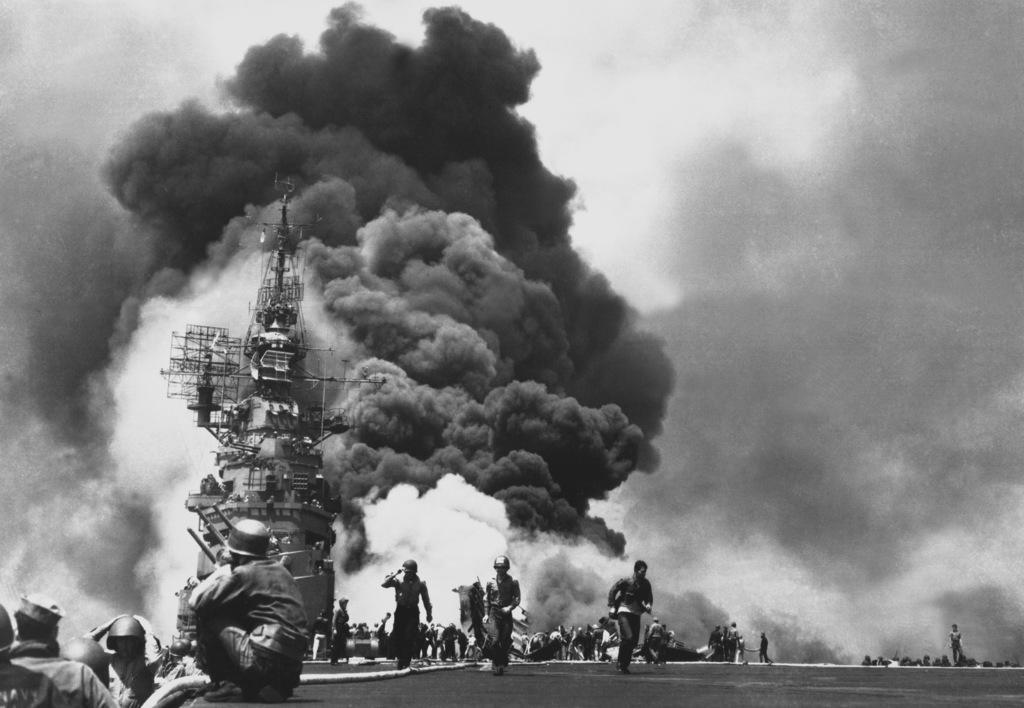Please provide a concise description of this image. In this image I can see number of people and I can see few of them are wearing helmets. In background I can see smoke and I can see this image is black and white in colour. 